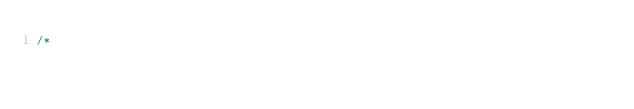Convert code to text. <code><loc_0><loc_0><loc_500><loc_500><_Java_>/*</code> 